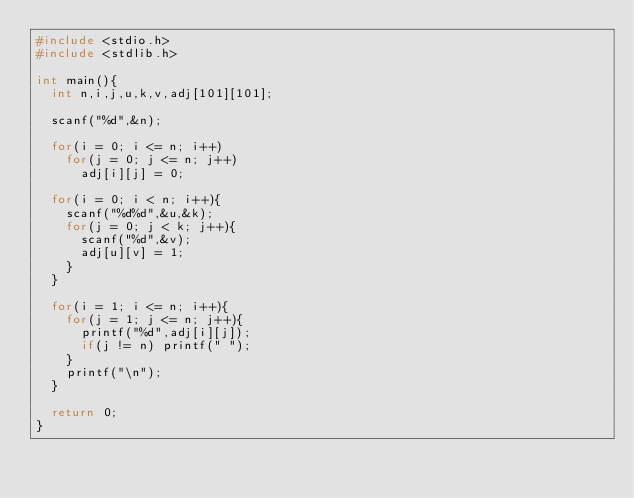<code> <loc_0><loc_0><loc_500><loc_500><_C_>#include <stdio.h>
#include <stdlib.h>

int main(){
  int n,i,j,u,k,v,adj[101][101];

  scanf("%d",&n);

  for(i = 0; i <= n; i++)
    for(j = 0; j <= n; j++)
      adj[i][j] = 0;
  
  for(i = 0; i < n; i++){
    scanf("%d%d",&u,&k);
    for(j = 0; j < k; j++){
      scanf("%d",&v);
      adj[u][v] = 1;
    }
  }

  for(i = 1; i <= n; i++){
    for(j = 1; j <= n; j++){
      printf("%d",adj[i][j]);
      if(j != n) printf(" ");
    }
    printf("\n");
  }

  return 0;
}
  
    
    
      

</code> 